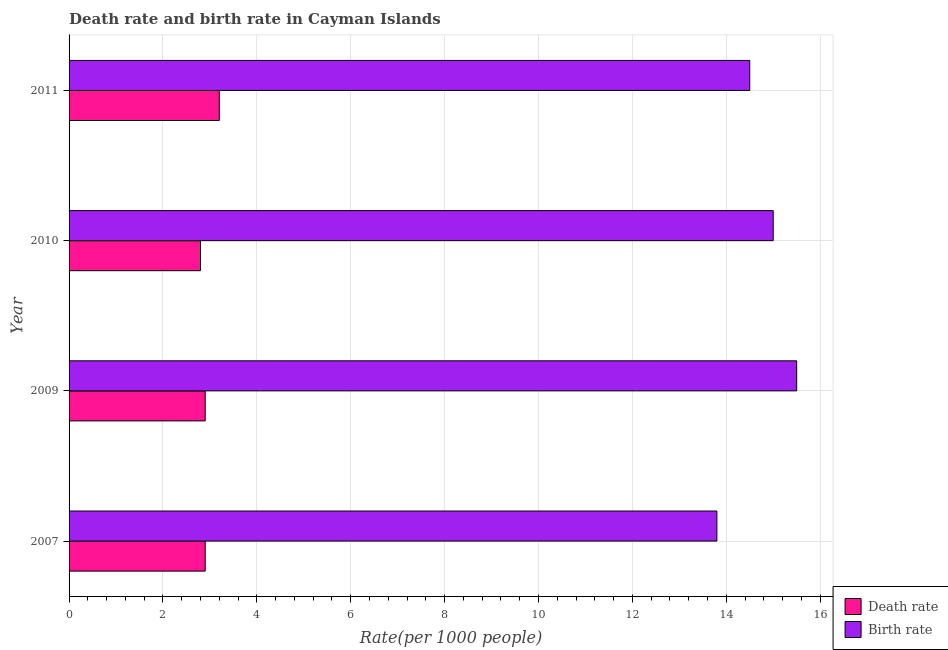How many groups of bars are there?
Your response must be concise. 4. Are the number of bars per tick equal to the number of legend labels?
Give a very brief answer. Yes. Are the number of bars on each tick of the Y-axis equal?
Ensure brevity in your answer.  Yes. How many bars are there on the 3rd tick from the top?
Keep it short and to the point. 2. In how many cases, is the number of bars for a given year not equal to the number of legend labels?
Your response must be concise. 0. What is the death rate in 2009?
Make the answer very short. 2.9. Across all years, what is the maximum death rate?
Make the answer very short. 3.2. In which year was the birth rate maximum?
Provide a succinct answer. 2009. In which year was the birth rate minimum?
Ensure brevity in your answer.  2007. What is the difference between the death rate in 2007 and the birth rate in 2011?
Ensure brevity in your answer.  -11.6. What is the average birth rate per year?
Provide a succinct answer. 14.7. In the year 2009, what is the difference between the death rate and birth rate?
Ensure brevity in your answer.  -12.6. In how many years, is the death rate greater than 10 ?
Your response must be concise. 0. What is the ratio of the birth rate in 2007 to that in 2009?
Offer a very short reply. 0.89. Is the difference between the death rate in 2007 and 2009 greater than the difference between the birth rate in 2007 and 2009?
Offer a terse response. Yes. What is the difference between the highest and the second highest death rate?
Offer a very short reply. 0.3. In how many years, is the birth rate greater than the average birth rate taken over all years?
Your response must be concise. 2. Is the sum of the death rate in 2009 and 2011 greater than the maximum birth rate across all years?
Provide a succinct answer. No. What does the 1st bar from the top in 2010 represents?
Offer a very short reply. Birth rate. What does the 1st bar from the bottom in 2011 represents?
Ensure brevity in your answer.  Death rate. Are all the bars in the graph horizontal?
Your answer should be compact. Yes. What is the difference between two consecutive major ticks on the X-axis?
Provide a short and direct response. 2. Are the values on the major ticks of X-axis written in scientific E-notation?
Give a very brief answer. No. Does the graph contain grids?
Provide a succinct answer. Yes. How many legend labels are there?
Your response must be concise. 2. What is the title of the graph?
Offer a very short reply. Death rate and birth rate in Cayman Islands. What is the label or title of the X-axis?
Your answer should be very brief. Rate(per 1000 people). What is the Rate(per 1000 people) in Death rate in 2007?
Your answer should be very brief. 2.9. What is the Rate(per 1000 people) in Death rate in 2009?
Keep it short and to the point. 2.9. What is the Rate(per 1000 people) in Birth rate in 2009?
Provide a short and direct response. 15.5. What is the Rate(per 1000 people) of Death rate in 2010?
Make the answer very short. 2.8. What is the Rate(per 1000 people) of Birth rate in 2010?
Make the answer very short. 15. Across all years, what is the maximum Rate(per 1000 people) of Death rate?
Keep it short and to the point. 3.2. Across all years, what is the maximum Rate(per 1000 people) of Birth rate?
Your answer should be compact. 15.5. Across all years, what is the minimum Rate(per 1000 people) in Death rate?
Ensure brevity in your answer.  2.8. What is the total Rate(per 1000 people) in Death rate in the graph?
Provide a succinct answer. 11.8. What is the total Rate(per 1000 people) of Birth rate in the graph?
Make the answer very short. 58.8. What is the difference between the Rate(per 1000 people) of Birth rate in 2007 and that in 2009?
Your response must be concise. -1.7. What is the difference between the Rate(per 1000 people) in Death rate in 2007 and that in 2011?
Your response must be concise. -0.3. What is the difference between the Rate(per 1000 people) in Birth rate in 2007 and that in 2011?
Make the answer very short. -0.7. What is the difference between the Rate(per 1000 people) of Death rate in 2009 and that in 2011?
Your answer should be very brief. -0.3. What is the difference between the Rate(per 1000 people) in Death rate in 2010 and that in 2011?
Your response must be concise. -0.4. What is the difference between the Rate(per 1000 people) in Birth rate in 2010 and that in 2011?
Offer a very short reply. 0.5. What is the difference between the Rate(per 1000 people) of Death rate in 2007 and the Rate(per 1000 people) of Birth rate in 2009?
Offer a terse response. -12.6. What is the difference between the Rate(per 1000 people) of Death rate in 2007 and the Rate(per 1000 people) of Birth rate in 2010?
Ensure brevity in your answer.  -12.1. What is the difference between the Rate(per 1000 people) in Death rate in 2009 and the Rate(per 1000 people) in Birth rate in 2011?
Give a very brief answer. -11.6. What is the difference between the Rate(per 1000 people) in Death rate in 2010 and the Rate(per 1000 people) in Birth rate in 2011?
Make the answer very short. -11.7. What is the average Rate(per 1000 people) of Death rate per year?
Provide a succinct answer. 2.95. What is the average Rate(per 1000 people) of Birth rate per year?
Keep it short and to the point. 14.7. In the year 2007, what is the difference between the Rate(per 1000 people) in Death rate and Rate(per 1000 people) in Birth rate?
Your answer should be very brief. -10.9. In the year 2010, what is the difference between the Rate(per 1000 people) of Death rate and Rate(per 1000 people) of Birth rate?
Your response must be concise. -12.2. In the year 2011, what is the difference between the Rate(per 1000 people) of Death rate and Rate(per 1000 people) of Birth rate?
Offer a very short reply. -11.3. What is the ratio of the Rate(per 1000 people) of Birth rate in 2007 to that in 2009?
Offer a terse response. 0.89. What is the ratio of the Rate(per 1000 people) in Death rate in 2007 to that in 2010?
Your response must be concise. 1.04. What is the ratio of the Rate(per 1000 people) in Death rate in 2007 to that in 2011?
Keep it short and to the point. 0.91. What is the ratio of the Rate(per 1000 people) of Birth rate in 2007 to that in 2011?
Your answer should be very brief. 0.95. What is the ratio of the Rate(per 1000 people) in Death rate in 2009 to that in 2010?
Your response must be concise. 1.04. What is the ratio of the Rate(per 1000 people) in Birth rate in 2009 to that in 2010?
Keep it short and to the point. 1.03. What is the ratio of the Rate(per 1000 people) of Death rate in 2009 to that in 2011?
Provide a short and direct response. 0.91. What is the ratio of the Rate(per 1000 people) in Birth rate in 2009 to that in 2011?
Your answer should be very brief. 1.07. What is the ratio of the Rate(per 1000 people) of Birth rate in 2010 to that in 2011?
Make the answer very short. 1.03. What is the difference between the highest and the lowest Rate(per 1000 people) of Death rate?
Your answer should be very brief. 0.4. What is the difference between the highest and the lowest Rate(per 1000 people) in Birth rate?
Your answer should be very brief. 1.7. 